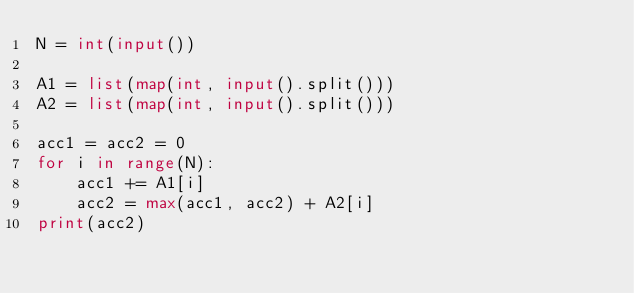Convert code to text. <code><loc_0><loc_0><loc_500><loc_500><_Python_>N = int(input())

A1 = list(map(int, input().split()))
A2 = list(map(int, input().split()))

acc1 = acc2 = 0
for i in range(N):
    acc1 += A1[i]
    acc2 = max(acc1, acc2) + A2[i]
print(acc2)
</code> 